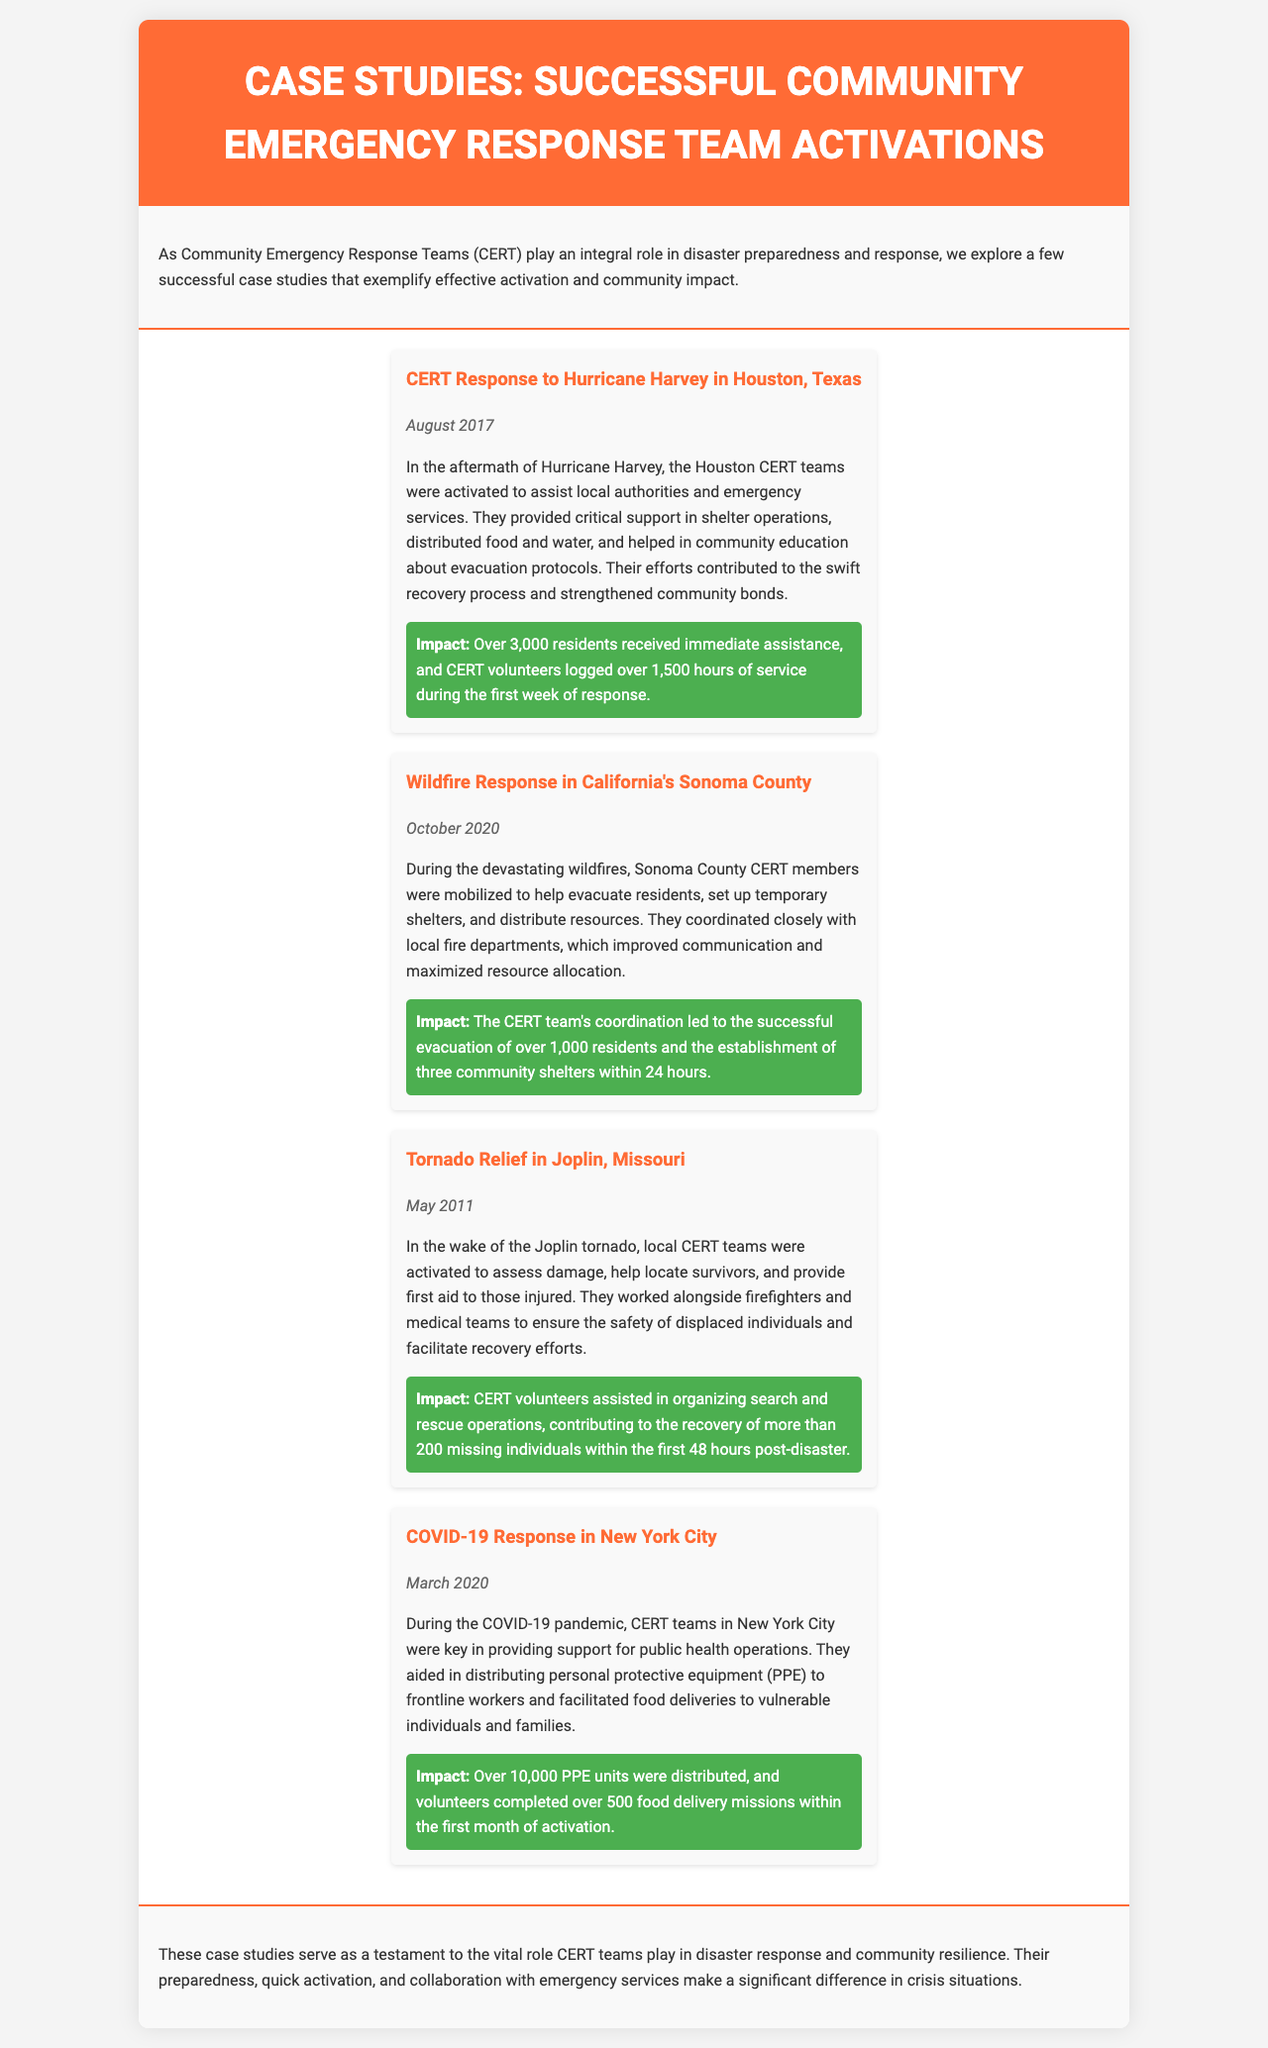What was the date of the Hurricane Harvey case study? This information can be found in the case study title, which includes the date of August 2017.
Answer: August 2017 How many residents received immediate assistance in the Hurricane Harvey response? The impact section states that over 3,000 residents received assistance.
Answer: Over 3,000 residents What month and year did the wildfire response in Sonoma County occur? The case study specifically states that the event took place in October 2020.
Answer: October 2020 How many community shelters were established during the Sonoma County wildfire response? The document mentions that three community shelters were established within 24 hours.
Answer: Three What was a significant action taken by CERT teams in response to the COVID-19 pandemic? The COVID-19 response section includes the distribution of personal protective equipment (PPE) to frontline workers.
Answer: Distribution of PPE What is the total number of food delivery missions completed during the COVID-19 response? The document reports that volunteers completed over 500 food delivery missions.
Answer: Over 500 missions Which case study describes actions taken after a tornado? The document clearly outlines actions taken in Joplin, Missouri, in the aftermath of a tornado.
Answer: Joplin, Missouri What was the primary role of CERT teams during the COVID-19 pandemic as stated in the newsletter? The newsletter describes that CERT teams were key in providing support for public health operations.
Answer: Support for public health operations What aspect of community response does the conclusion emphasize? The conclusion highlights the vital role CERT teams play in disaster response and community resilience.
Answer: Vital role in disaster response 